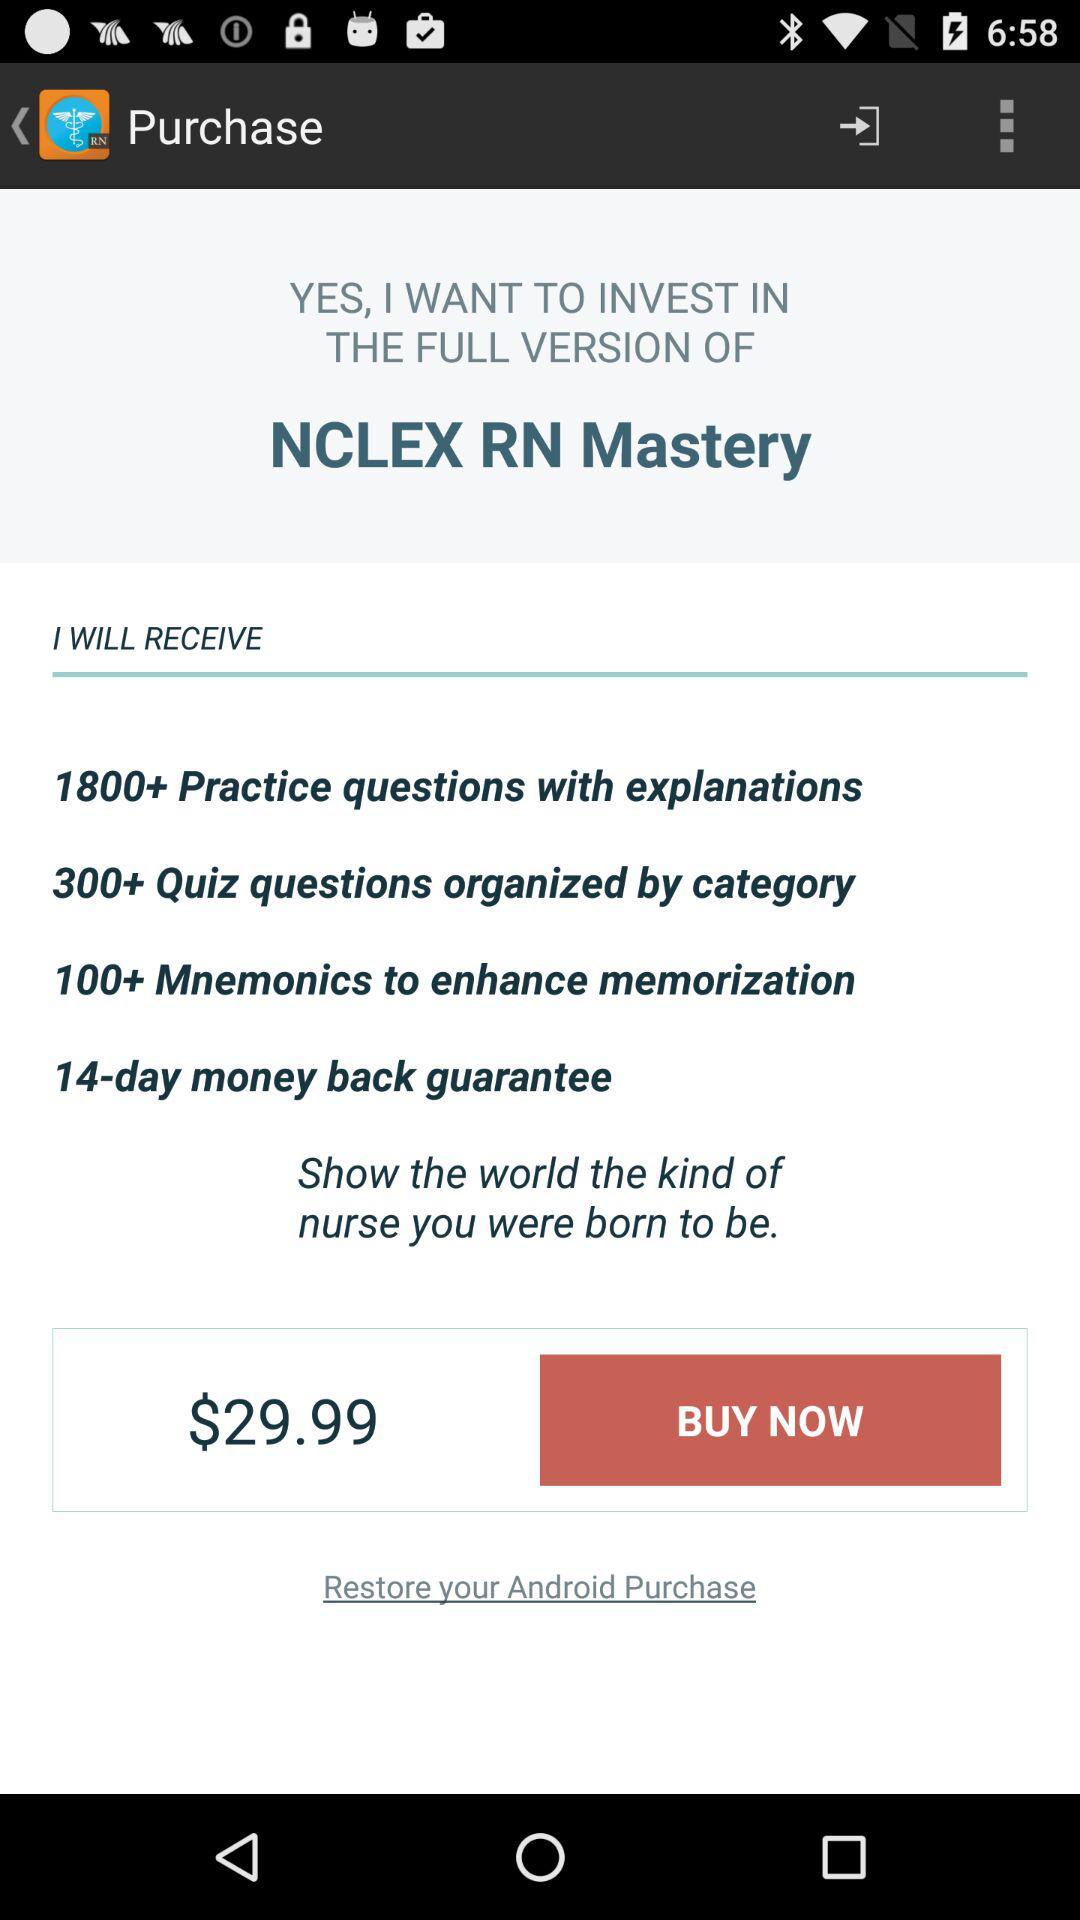What is the price of the full version of "NCLEX RN Mastery"? The price of the full version of "NCLEX RN Mastery" is $29.99. 